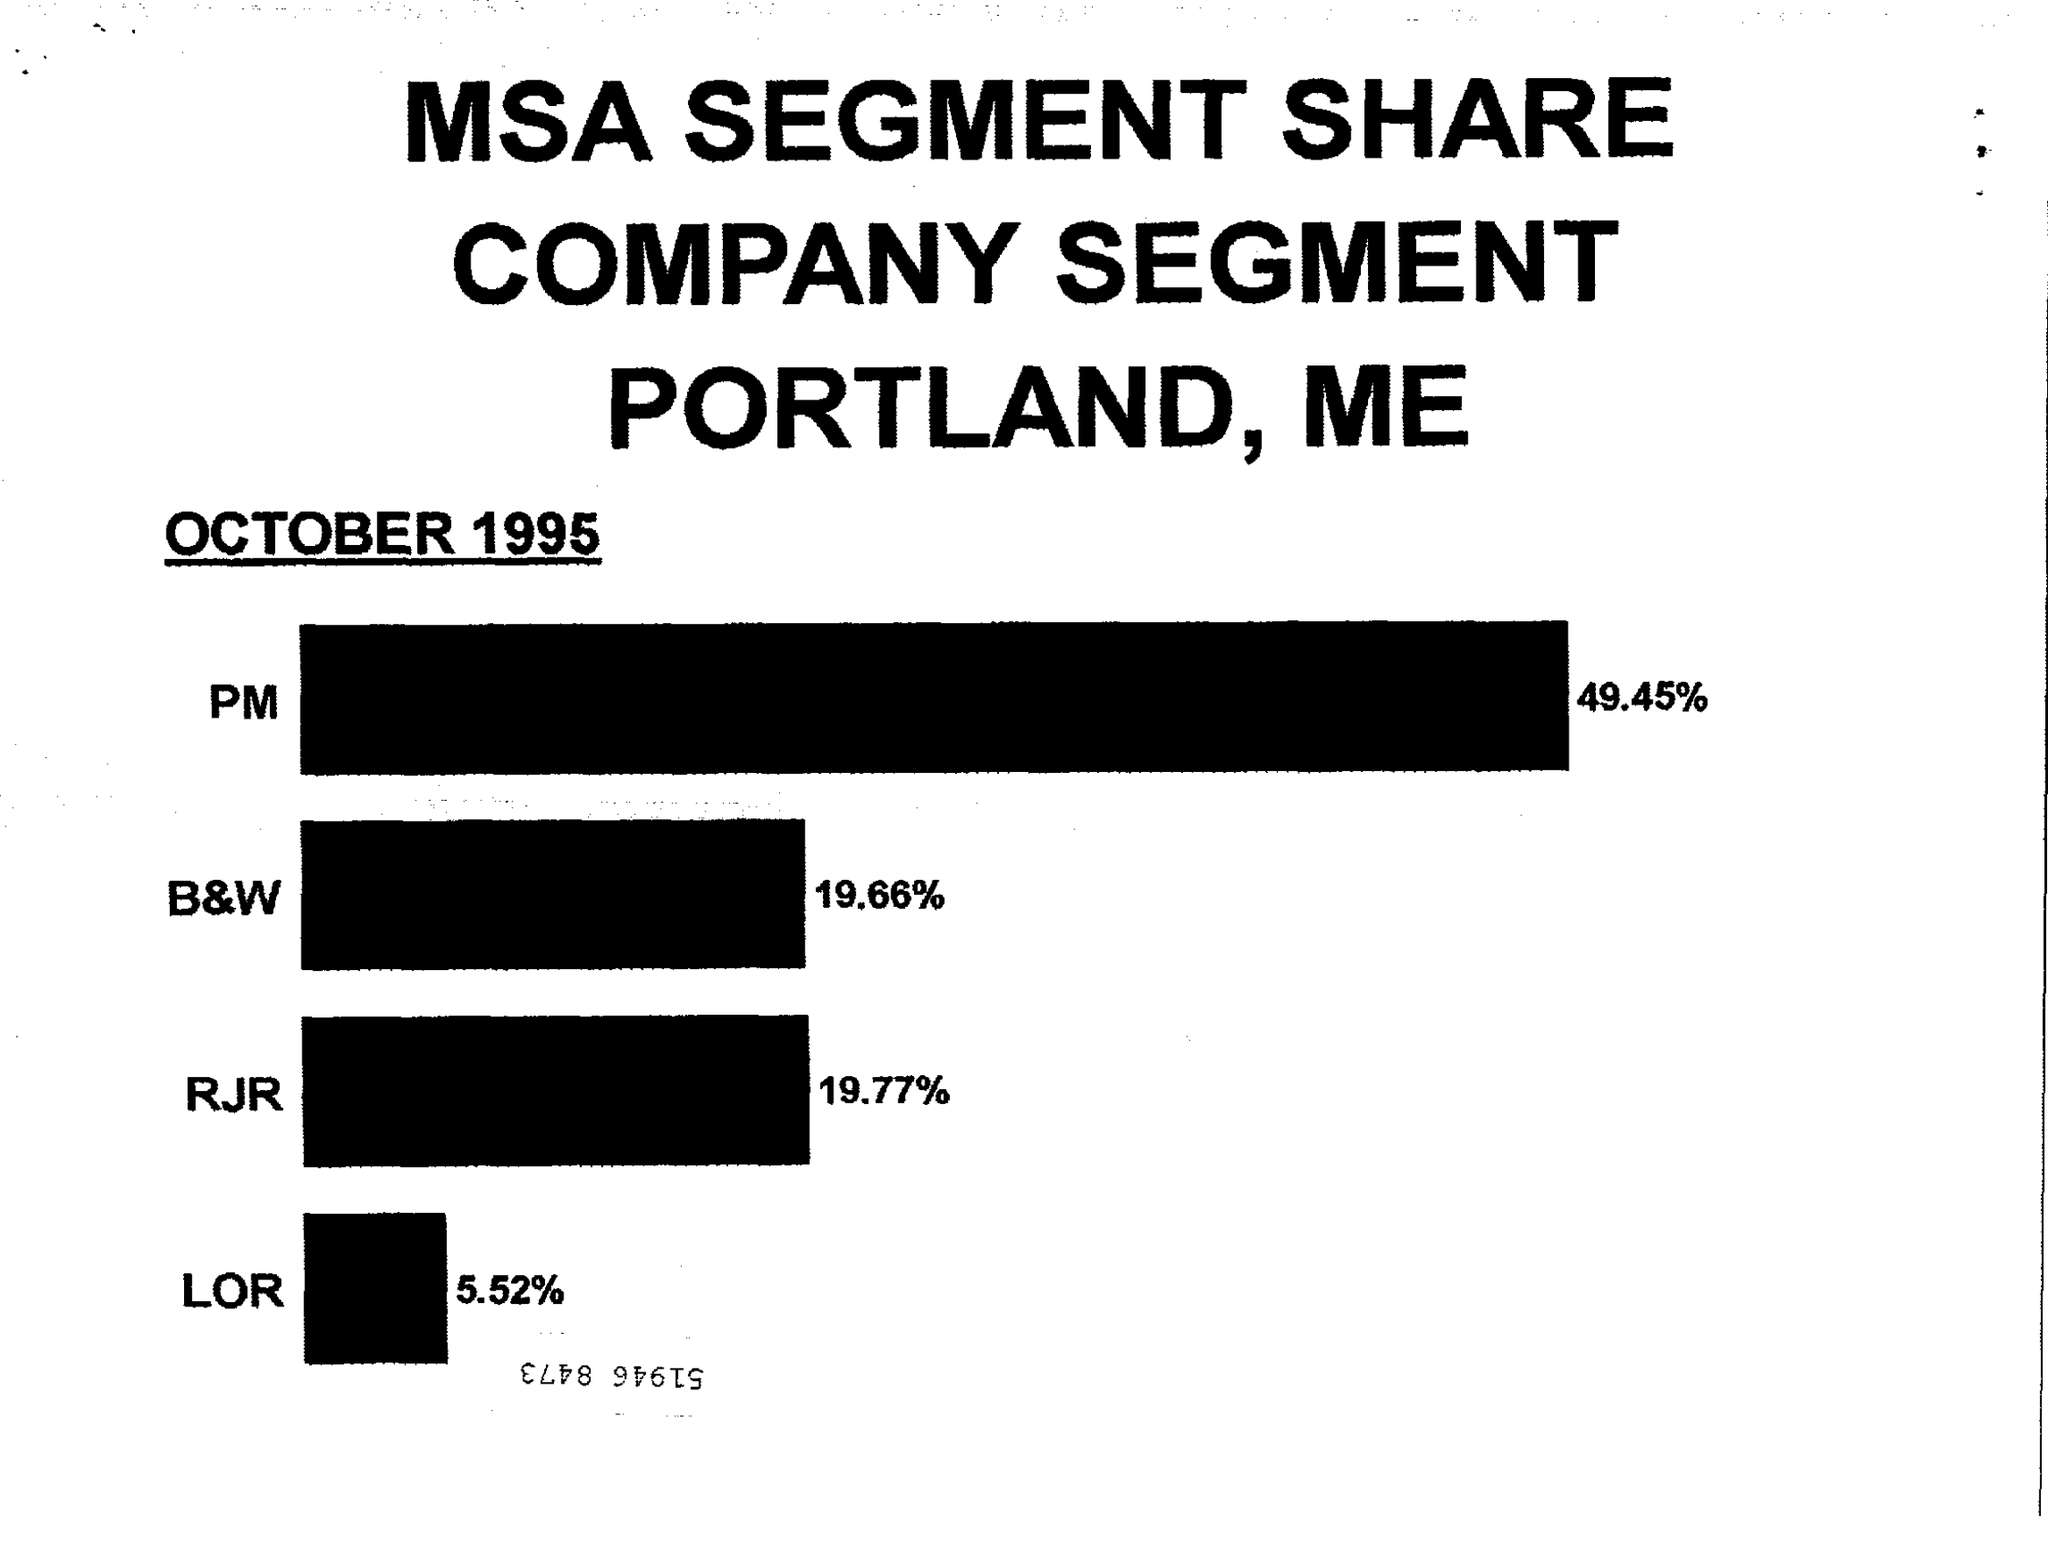Draw attention to some important aspects in this diagram. The MSA SEGMENT SHARE was dated as OCTOBER 1995. The percentage of PM is 49.45... 